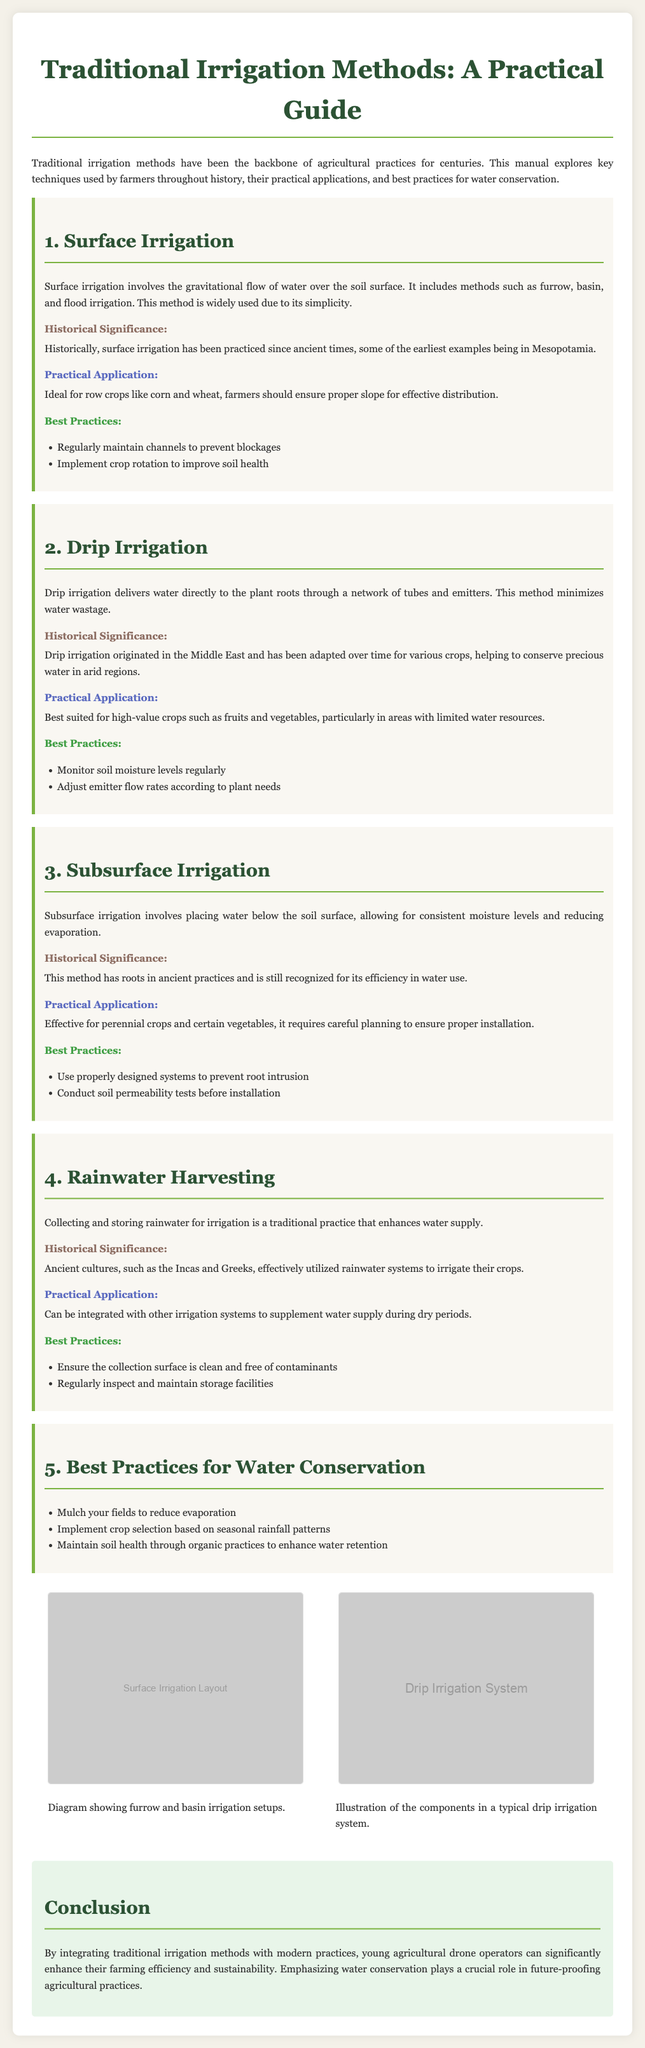What are the four traditional irrigation methods mentioned? The document outlines four traditional irrigation methods: Surface Irrigation, Drip Irrigation, Subsurface Irrigation, and Rainwater Harvesting.
Answer: Surface Irrigation, Drip Irrigation, Subsurface Irrigation, Rainwater Harvesting Which historical culture is noted for utilizing rainwater systems? The document states that ancient cultures such as the Incas and Greeks effectively utilized rainwater systems for irrigation.
Answer: Incas and Greeks What is the main benefit of drip irrigation? The document specifies that drip irrigation minimizes water wastage by delivering water directly to plant roots.
Answer: Minimizes water wastage Which crops are best suited for subsurface irrigation? According to the document, subsurface irrigation is effective for perennial crops and certain vegetables.
Answer: Perennial crops and certain vegetables What is one best practice for rainwater harvesting? The manual suggests ensuring the collection surface is clean and free of contaminants as a best practice for rainwater harvesting.
Answer: Clean and free of contaminants What is the primary purpose of the manual? The purpose of the manual is to explore traditional irrigation techniques, their historical significance, and best practices for water conservation.
Answer: Explore traditional irrigation techniques, historical significance, and best practices for water conservation What diagram is provided for surface irrigation? The document includes a diagram showing furrow and basin irrigation setups for surface irrigation.
Answer: Furrow and basin irrigation setups Which irrigation method requires careful planning for proper installation? The document notes that subsurface irrigation requires careful planning to ensure proper installation.
Answer: Subsurface irrigation 